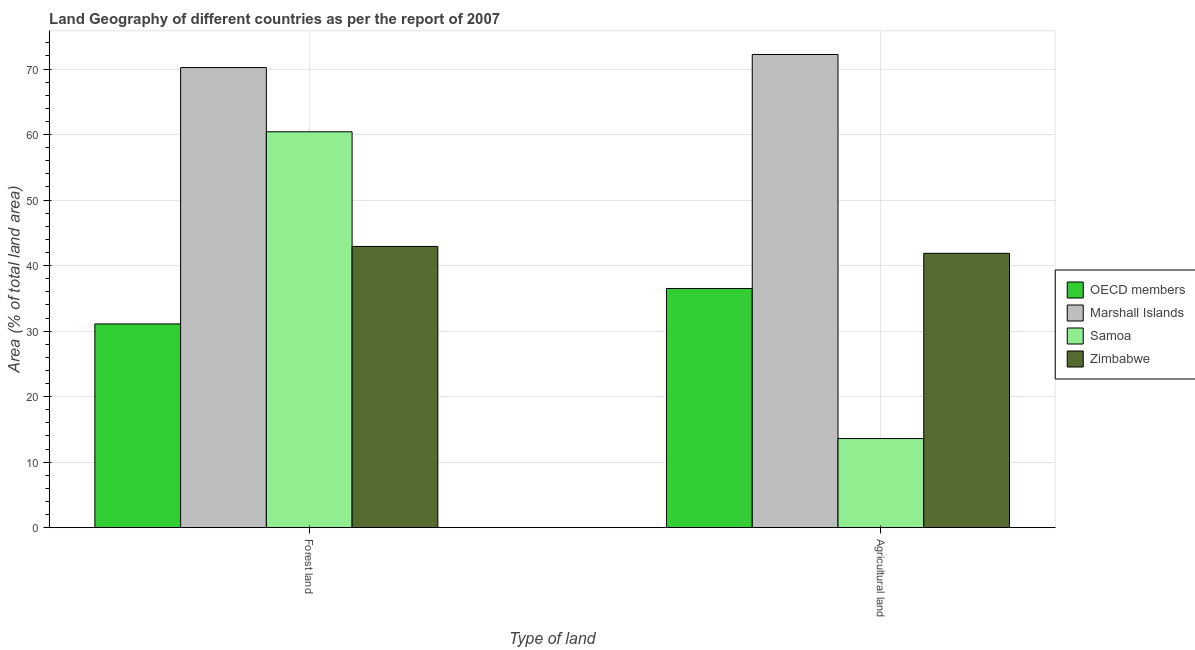How many different coloured bars are there?
Your response must be concise. 4. How many groups of bars are there?
Ensure brevity in your answer.  2. Are the number of bars on each tick of the X-axis equal?
Make the answer very short. Yes. How many bars are there on the 2nd tick from the right?
Provide a succinct answer. 4. What is the label of the 1st group of bars from the left?
Keep it short and to the point. Forest land. What is the percentage of land area under forests in OECD members?
Offer a terse response. 31.1. Across all countries, what is the maximum percentage of land area under forests?
Offer a very short reply. 70.22. Across all countries, what is the minimum percentage of land area under agriculture?
Your answer should be compact. 13.6. In which country was the percentage of land area under agriculture maximum?
Your response must be concise. Marshall Islands. In which country was the percentage of land area under agriculture minimum?
Make the answer very short. Samoa. What is the total percentage of land area under forests in the graph?
Provide a succinct answer. 204.67. What is the difference between the percentage of land area under agriculture in Zimbabwe and that in OECD members?
Keep it short and to the point. 5.37. What is the difference between the percentage of land area under agriculture in OECD members and the percentage of land area under forests in Samoa?
Give a very brief answer. -23.92. What is the average percentage of land area under agriculture per country?
Provide a short and direct response. 41.05. What is the difference between the percentage of land area under forests and percentage of land area under agriculture in Samoa?
Your answer should be very brief. 46.82. In how many countries, is the percentage of land area under forests greater than 46 %?
Give a very brief answer. 2. What is the ratio of the percentage of land area under forests in Samoa to that in Marshall Islands?
Offer a very short reply. 0.86. Is the percentage of land area under forests in OECD members less than that in Marshall Islands?
Provide a succinct answer. Yes. In how many countries, is the percentage of land area under agriculture greater than the average percentage of land area under agriculture taken over all countries?
Ensure brevity in your answer.  2. What does the 4th bar from the left in Forest land represents?
Ensure brevity in your answer.  Zimbabwe. How many bars are there?
Offer a terse response. 8. How many countries are there in the graph?
Ensure brevity in your answer.  4. What is the difference between two consecutive major ticks on the Y-axis?
Offer a terse response. 10. Does the graph contain any zero values?
Give a very brief answer. No. Does the graph contain grids?
Keep it short and to the point. Yes. Where does the legend appear in the graph?
Ensure brevity in your answer.  Center right. What is the title of the graph?
Keep it short and to the point. Land Geography of different countries as per the report of 2007. What is the label or title of the X-axis?
Offer a very short reply. Type of land. What is the label or title of the Y-axis?
Your response must be concise. Area (% of total land area). What is the Area (% of total land area) of OECD members in Forest land?
Keep it short and to the point. 31.1. What is the Area (% of total land area) of Marshall Islands in Forest land?
Offer a terse response. 70.22. What is the Area (% of total land area) of Samoa in Forest land?
Your answer should be compact. 60.42. What is the Area (% of total land area) of Zimbabwe in Forest land?
Provide a succinct answer. 42.92. What is the Area (% of total land area) in OECD members in Agricultural land?
Provide a succinct answer. 36.51. What is the Area (% of total land area) of Marshall Islands in Agricultural land?
Your answer should be very brief. 72.22. What is the Area (% of total land area) of Samoa in Agricultural land?
Provide a short and direct response. 13.6. What is the Area (% of total land area) of Zimbabwe in Agricultural land?
Give a very brief answer. 41.88. Across all Type of land, what is the maximum Area (% of total land area) in OECD members?
Keep it short and to the point. 36.51. Across all Type of land, what is the maximum Area (% of total land area) of Marshall Islands?
Your answer should be very brief. 72.22. Across all Type of land, what is the maximum Area (% of total land area) of Samoa?
Provide a succinct answer. 60.42. Across all Type of land, what is the maximum Area (% of total land area) of Zimbabwe?
Give a very brief answer. 42.92. Across all Type of land, what is the minimum Area (% of total land area) in OECD members?
Your response must be concise. 31.1. Across all Type of land, what is the minimum Area (% of total land area) of Marshall Islands?
Provide a succinct answer. 70.22. Across all Type of land, what is the minimum Area (% of total land area) in Samoa?
Make the answer very short. 13.6. Across all Type of land, what is the minimum Area (% of total land area) of Zimbabwe?
Offer a very short reply. 41.88. What is the total Area (% of total land area) of OECD members in the graph?
Provide a succinct answer. 67.61. What is the total Area (% of total land area) in Marshall Islands in the graph?
Keep it short and to the point. 142.44. What is the total Area (% of total land area) in Samoa in the graph?
Keep it short and to the point. 74.03. What is the total Area (% of total land area) in Zimbabwe in the graph?
Ensure brevity in your answer.  84.8. What is the difference between the Area (% of total land area) in OECD members in Forest land and that in Agricultural land?
Offer a very short reply. -5.41. What is the difference between the Area (% of total land area) of Samoa in Forest land and that in Agricultural land?
Provide a succinct answer. 46.82. What is the difference between the Area (% of total land area) of Zimbabwe in Forest land and that in Agricultural land?
Offer a terse response. 1.05. What is the difference between the Area (% of total land area) of OECD members in Forest land and the Area (% of total land area) of Marshall Islands in Agricultural land?
Your response must be concise. -41.12. What is the difference between the Area (% of total land area) of OECD members in Forest land and the Area (% of total land area) of Samoa in Agricultural land?
Your answer should be compact. 17.49. What is the difference between the Area (% of total land area) of OECD members in Forest land and the Area (% of total land area) of Zimbabwe in Agricultural land?
Your answer should be very brief. -10.78. What is the difference between the Area (% of total land area) of Marshall Islands in Forest land and the Area (% of total land area) of Samoa in Agricultural land?
Make the answer very short. 56.62. What is the difference between the Area (% of total land area) in Marshall Islands in Forest land and the Area (% of total land area) in Zimbabwe in Agricultural land?
Ensure brevity in your answer.  28.35. What is the difference between the Area (% of total land area) in Samoa in Forest land and the Area (% of total land area) in Zimbabwe in Agricultural land?
Your answer should be very brief. 18.55. What is the average Area (% of total land area) of OECD members per Type of land?
Offer a very short reply. 33.8. What is the average Area (% of total land area) in Marshall Islands per Type of land?
Ensure brevity in your answer.  71.22. What is the average Area (% of total land area) of Samoa per Type of land?
Ensure brevity in your answer.  37.01. What is the average Area (% of total land area) in Zimbabwe per Type of land?
Offer a terse response. 42.4. What is the difference between the Area (% of total land area) in OECD members and Area (% of total land area) in Marshall Islands in Forest land?
Offer a terse response. -39.12. What is the difference between the Area (% of total land area) in OECD members and Area (% of total land area) in Samoa in Forest land?
Ensure brevity in your answer.  -29.32. What is the difference between the Area (% of total land area) in OECD members and Area (% of total land area) in Zimbabwe in Forest land?
Make the answer very short. -11.82. What is the difference between the Area (% of total land area) in Marshall Islands and Area (% of total land area) in Samoa in Forest land?
Give a very brief answer. 9.8. What is the difference between the Area (% of total land area) of Marshall Islands and Area (% of total land area) of Zimbabwe in Forest land?
Your answer should be very brief. 27.3. What is the difference between the Area (% of total land area) in Samoa and Area (% of total land area) in Zimbabwe in Forest land?
Offer a terse response. 17.5. What is the difference between the Area (% of total land area) of OECD members and Area (% of total land area) of Marshall Islands in Agricultural land?
Provide a short and direct response. -35.71. What is the difference between the Area (% of total land area) of OECD members and Area (% of total land area) of Samoa in Agricultural land?
Provide a short and direct response. 22.9. What is the difference between the Area (% of total land area) of OECD members and Area (% of total land area) of Zimbabwe in Agricultural land?
Your answer should be compact. -5.37. What is the difference between the Area (% of total land area) in Marshall Islands and Area (% of total land area) in Samoa in Agricultural land?
Your answer should be compact. 58.62. What is the difference between the Area (% of total land area) in Marshall Islands and Area (% of total land area) in Zimbabwe in Agricultural land?
Your answer should be very brief. 30.35. What is the difference between the Area (% of total land area) in Samoa and Area (% of total land area) in Zimbabwe in Agricultural land?
Offer a very short reply. -28.27. What is the ratio of the Area (% of total land area) in OECD members in Forest land to that in Agricultural land?
Keep it short and to the point. 0.85. What is the ratio of the Area (% of total land area) of Marshall Islands in Forest land to that in Agricultural land?
Offer a terse response. 0.97. What is the ratio of the Area (% of total land area) in Samoa in Forest land to that in Agricultural land?
Your answer should be very brief. 4.44. What is the difference between the highest and the second highest Area (% of total land area) in OECD members?
Keep it short and to the point. 5.41. What is the difference between the highest and the second highest Area (% of total land area) of Samoa?
Make the answer very short. 46.82. What is the difference between the highest and the second highest Area (% of total land area) in Zimbabwe?
Provide a short and direct response. 1.05. What is the difference between the highest and the lowest Area (% of total land area) in OECD members?
Your answer should be very brief. 5.41. What is the difference between the highest and the lowest Area (% of total land area) of Marshall Islands?
Your answer should be compact. 2. What is the difference between the highest and the lowest Area (% of total land area) of Samoa?
Your answer should be very brief. 46.82. What is the difference between the highest and the lowest Area (% of total land area) in Zimbabwe?
Offer a very short reply. 1.05. 